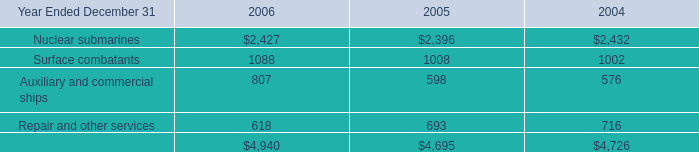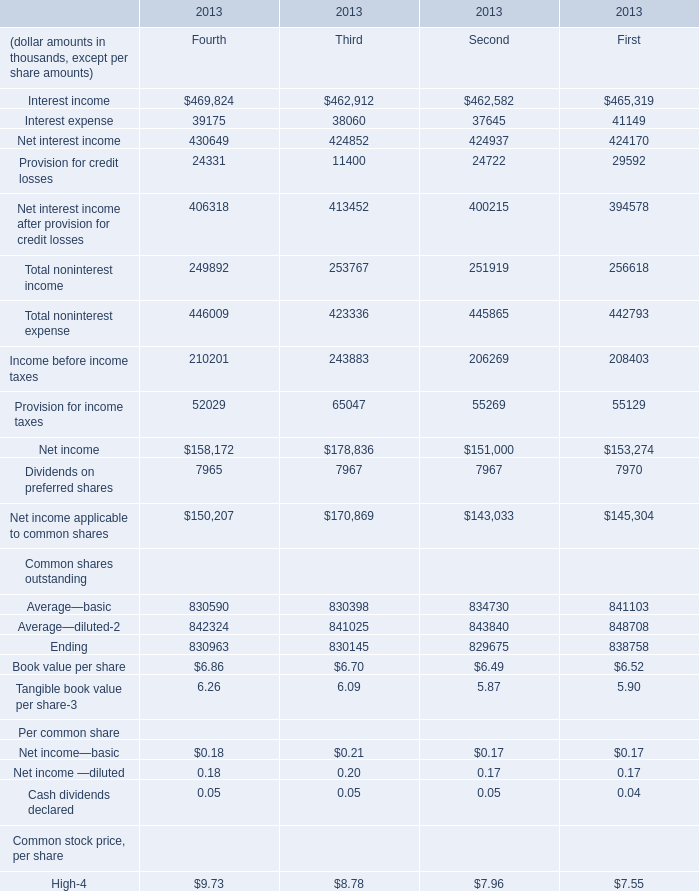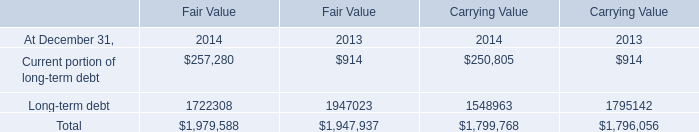what is the highest total amount of Close? (in thousand) 
Answer: 9.65. 